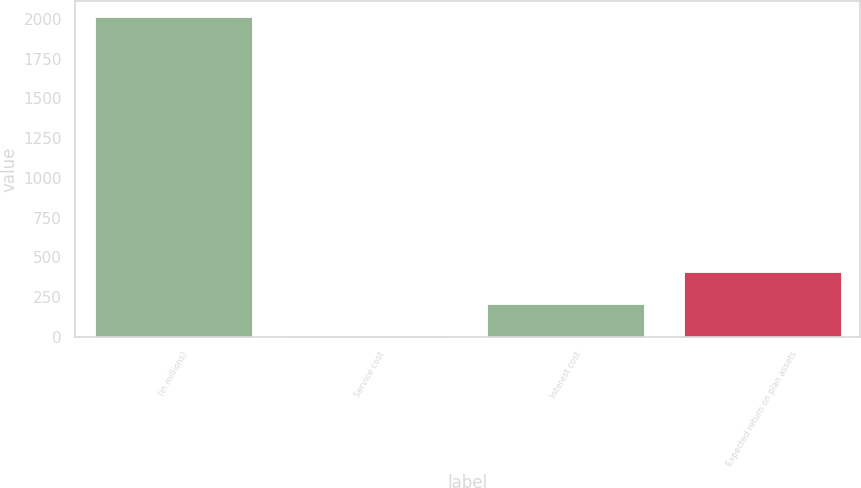Convert chart. <chart><loc_0><loc_0><loc_500><loc_500><bar_chart><fcel>(in millions)<fcel>Service cost<fcel>Interest cost<fcel>Expected return on plan assets<nl><fcel>2013<fcel>5<fcel>205.8<fcel>406.6<nl></chart> 